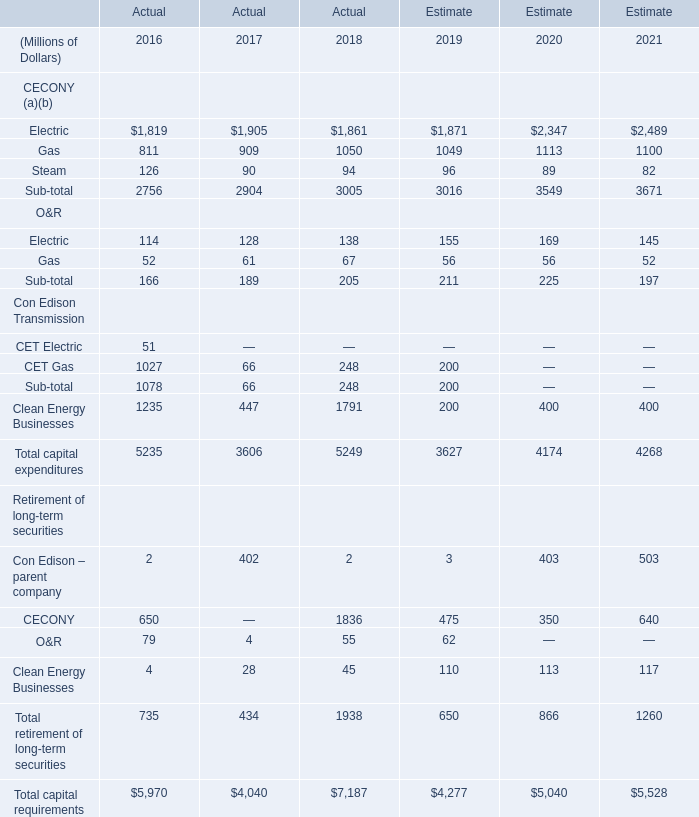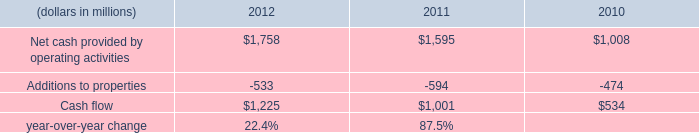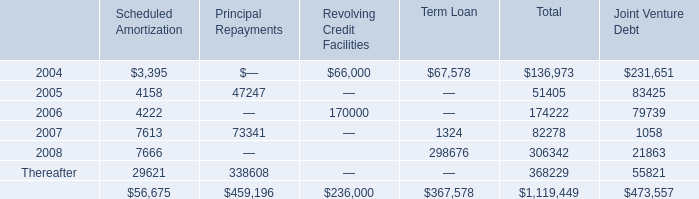What's the sum of Gas of Estimate 2019, and Net cash provided by operating activities of 2011 ? 
Computations: (1049.0 + 1595.0)
Answer: 2644.0. 